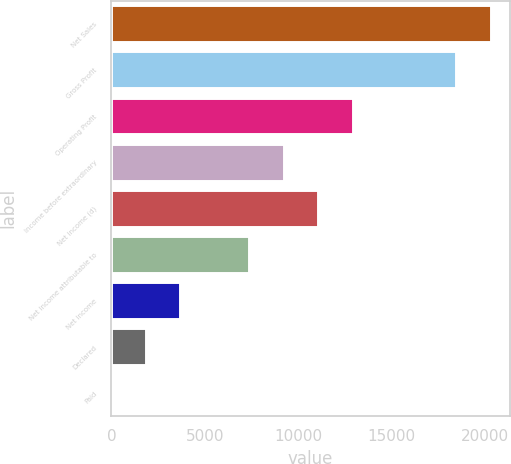Convert chart to OTSL. <chart><loc_0><loc_0><loc_500><loc_500><bar_chart><fcel>Net Sales<fcel>Gross Profit<fcel>Operating Profit<fcel>Income before extraordinary<fcel>Net income (d)<fcel>Net income attributable to<fcel>Net income<fcel>Declared<fcel>Paid<nl><fcel>20283.8<fcel>18440<fcel>12908.6<fcel>9221.03<fcel>11064.8<fcel>7377.24<fcel>3689.66<fcel>1845.87<fcel>2.08<nl></chart> 